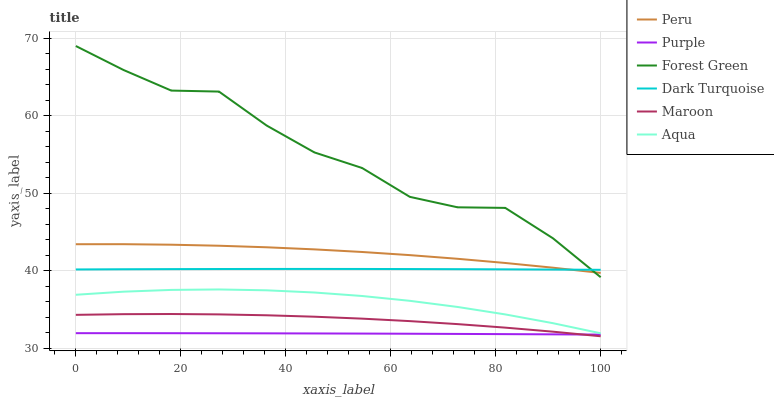Does Purple have the minimum area under the curve?
Answer yes or no. Yes. Does Forest Green have the maximum area under the curve?
Answer yes or no. Yes. Does Dark Turquoise have the minimum area under the curve?
Answer yes or no. No. Does Dark Turquoise have the maximum area under the curve?
Answer yes or no. No. Is Purple the smoothest?
Answer yes or no. Yes. Is Forest Green the roughest?
Answer yes or no. Yes. Is Dark Turquoise the smoothest?
Answer yes or no. No. Is Dark Turquoise the roughest?
Answer yes or no. No. Does Maroon have the lowest value?
Answer yes or no. Yes. Does Aqua have the lowest value?
Answer yes or no. No. Does Forest Green have the highest value?
Answer yes or no. Yes. Does Dark Turquoise have the highest value?
Answer yes or no. No. Is Purple less than Aqua?
Answer yes or no. Yes. Is Aqua greater than Maroon?
Answer yes or no. Yes. Does Forest Green intersect Peru?
Answer yes or no. Yes. Is Forest Green less than Peru?
Answer yes or no. No. Is Forest Green greater than Peru?
Answer yes or no. No. Does Purple intersect Aqua?
Answer yes or no. No. 